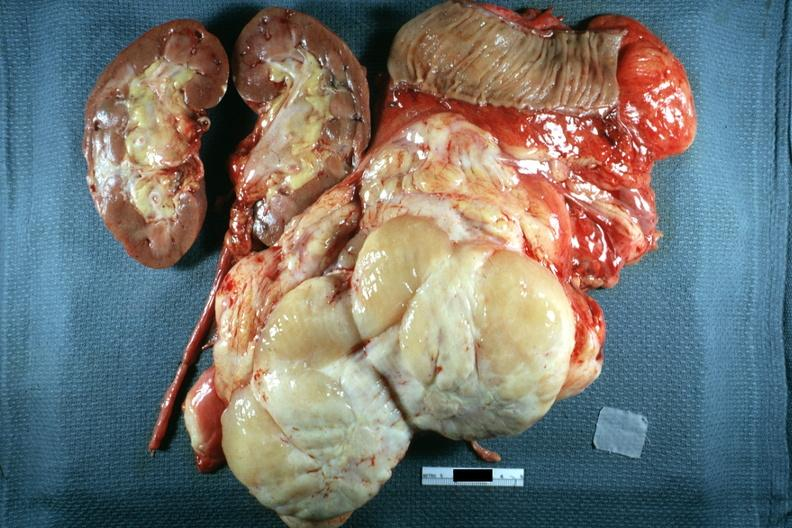what sectioned to show cut surface kidney portion of jejunum shown in this surgically resected specimen excellent?
Answer the question using a single word or phrase. Nodular tumor 